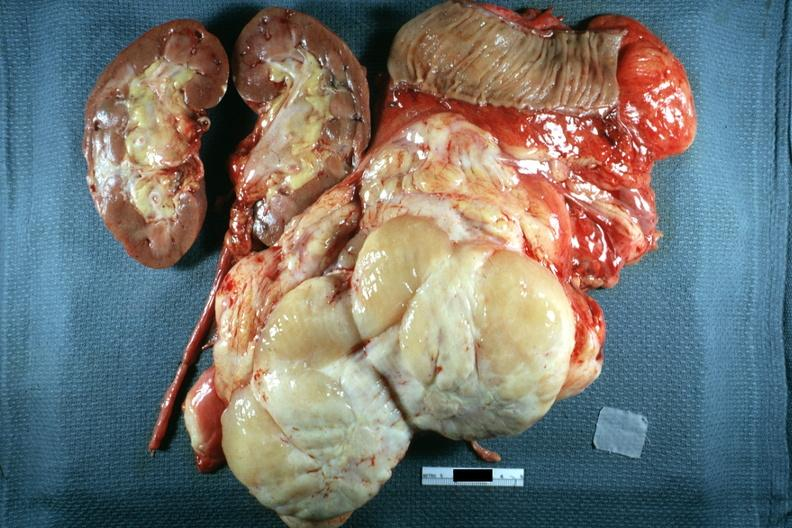what sectioned to show cut surface kidney portion of jejunum shown in this surgically resected specimen excellent?
Answer the question using a single word or phrase. Nodular tumor 